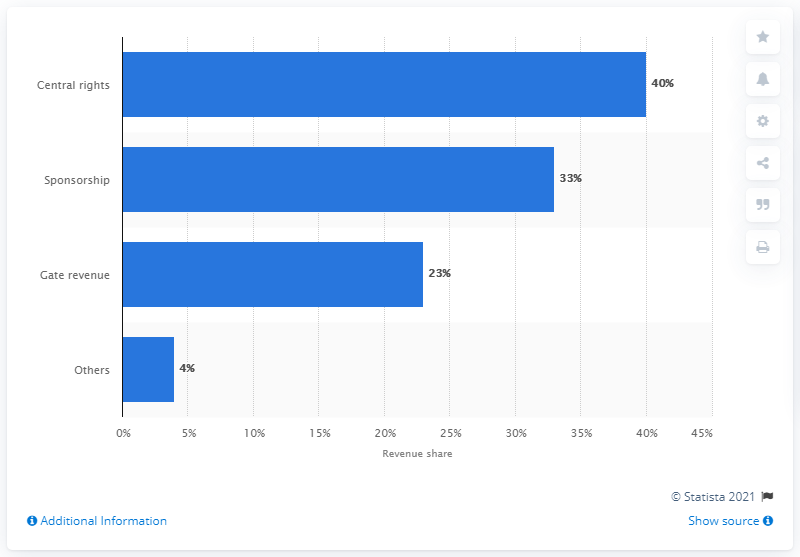Identify some key points in this picture. The category that is 10 times more than 'others' is 'Central rights.' The revenue generated from Gates as a percentage of total revenue is 23%. 